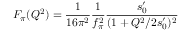Convert formula to latex. <formula><loc_0><loc_0><loc_500><loc_500>F _ { \pi } ( Q ^ { 2 } ) = \frac { 1 } { 1 6 \pi ^ { 2 } } \frac { 1 } { f _ { \pi } ^ { 2 } } \frac { s _ { 0 } ^ { \prime } } { ( 1 + Q ^ { 2 } / 2 s _ { 0 } ^ { \prime } ) ^ { 2 } }</formula> 